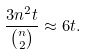<formula> <loc_0><loc_0><loc_500><loc_500>\frac { 3 n ^ { 2 } t } { \binom { n } { 2 } } \approx 6 t .</formula> 